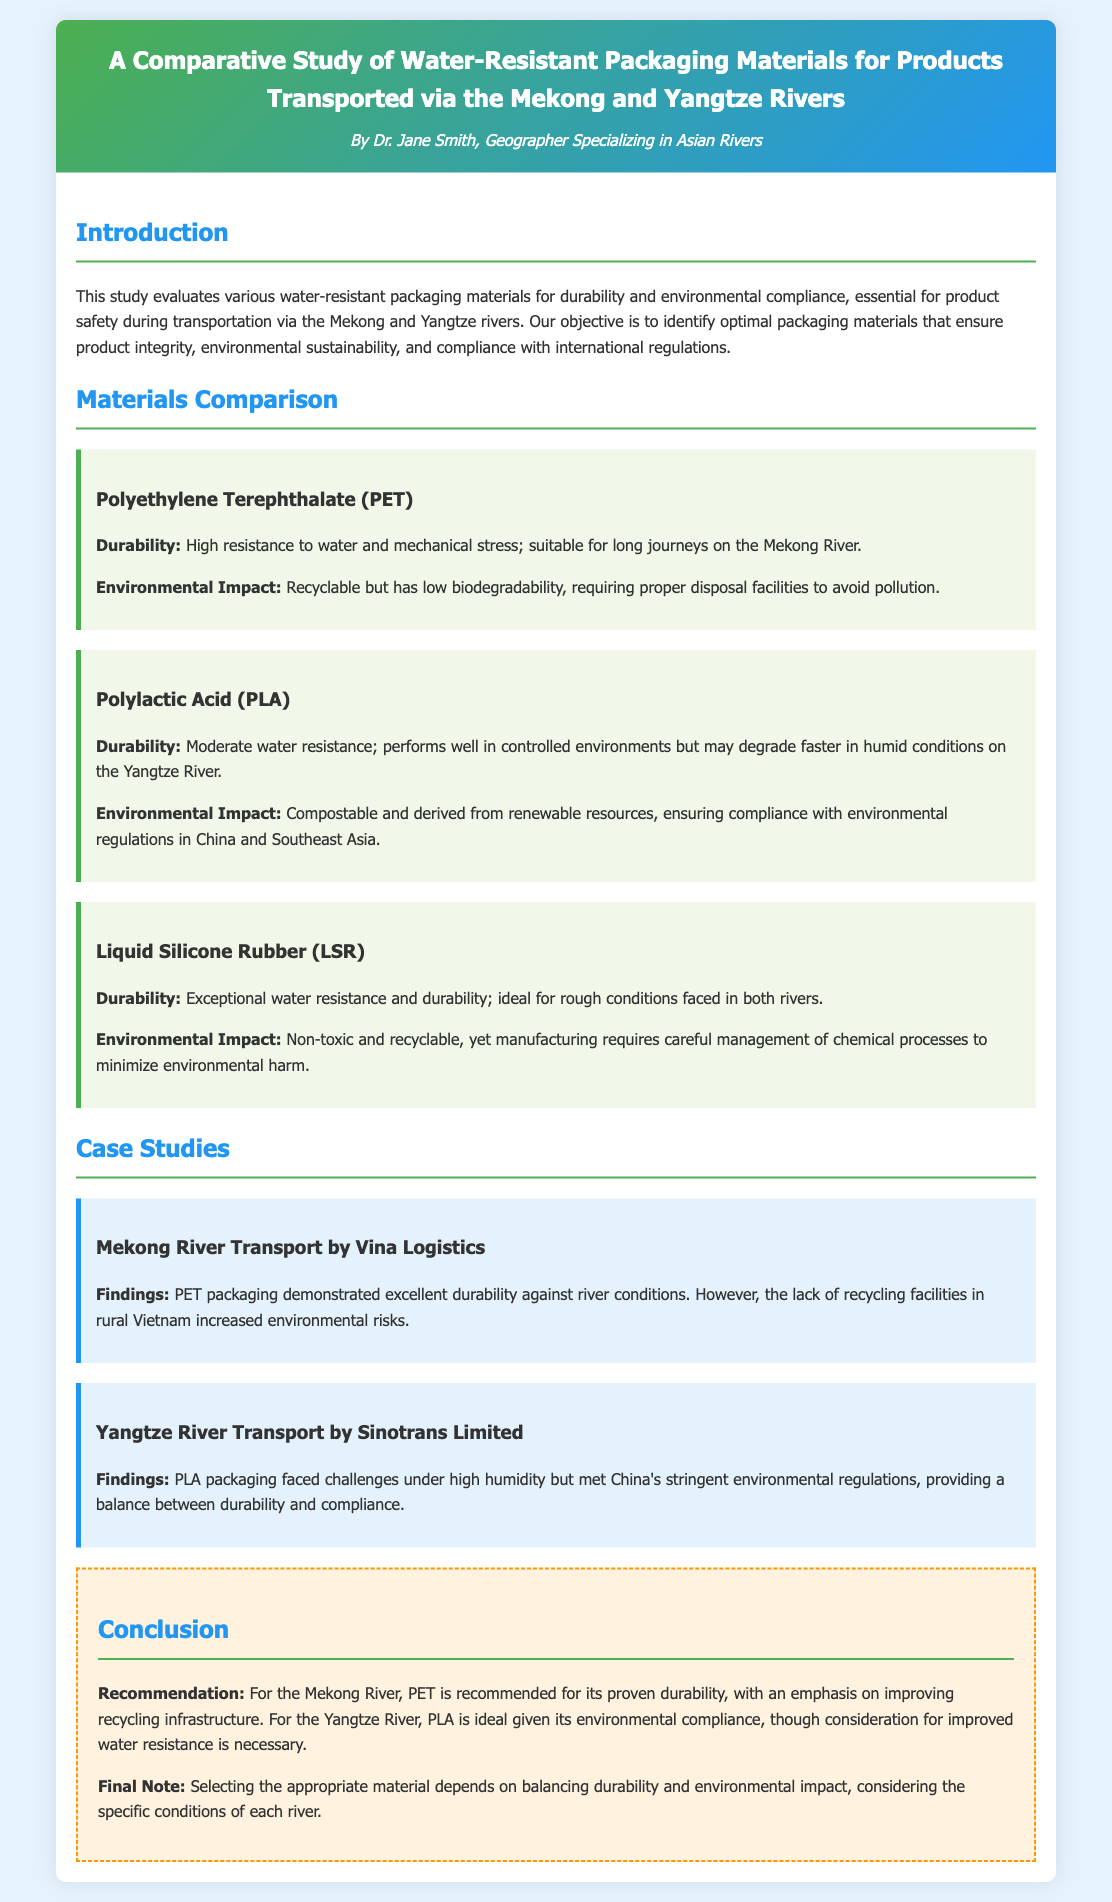What are the two rivers studied in the document? The document focuses on two specific rivers: the Mekong and the Yangtze, as indicated in the title and introduction.
Answer: Mekong and Yangtze Who is the author of the study? The author of the study is introduced in the header section of the document.
Answer: Dr. Jane Smith What packaging material is recommended for the Mekong River? The recommendation for the Mekong River is stated in the conclusion section of the document.
Answer: PET What is the main environmental compliance material identified for the Yangtze River? The conclusion section specifies the material that meets environmental regulations for the Yangtze River.
Answer: PLA Which material has exceptional water resistance? The durability section of the document outlines the materials' properties, listing this specific one.
Answer: Liquid Silicone Rubber What did the case study on the Mekong River highlight regarding PET packaging? The findings mention the key points of PET packaging's performance in the Mekong River case study.
Answer: Excellent durability What challenge did PLA packaging face on the Yangtze River? The document notes the difficulties encountered regarding PLA packaging in the case study for the Yangtze River.
Answer: High humidity What is the final recommendation for handling environmental impact when selecting materials? The conclusion emphasizes balancing durability and environmental impact in material selection.
Answer: Balancing durability and environmental impact 